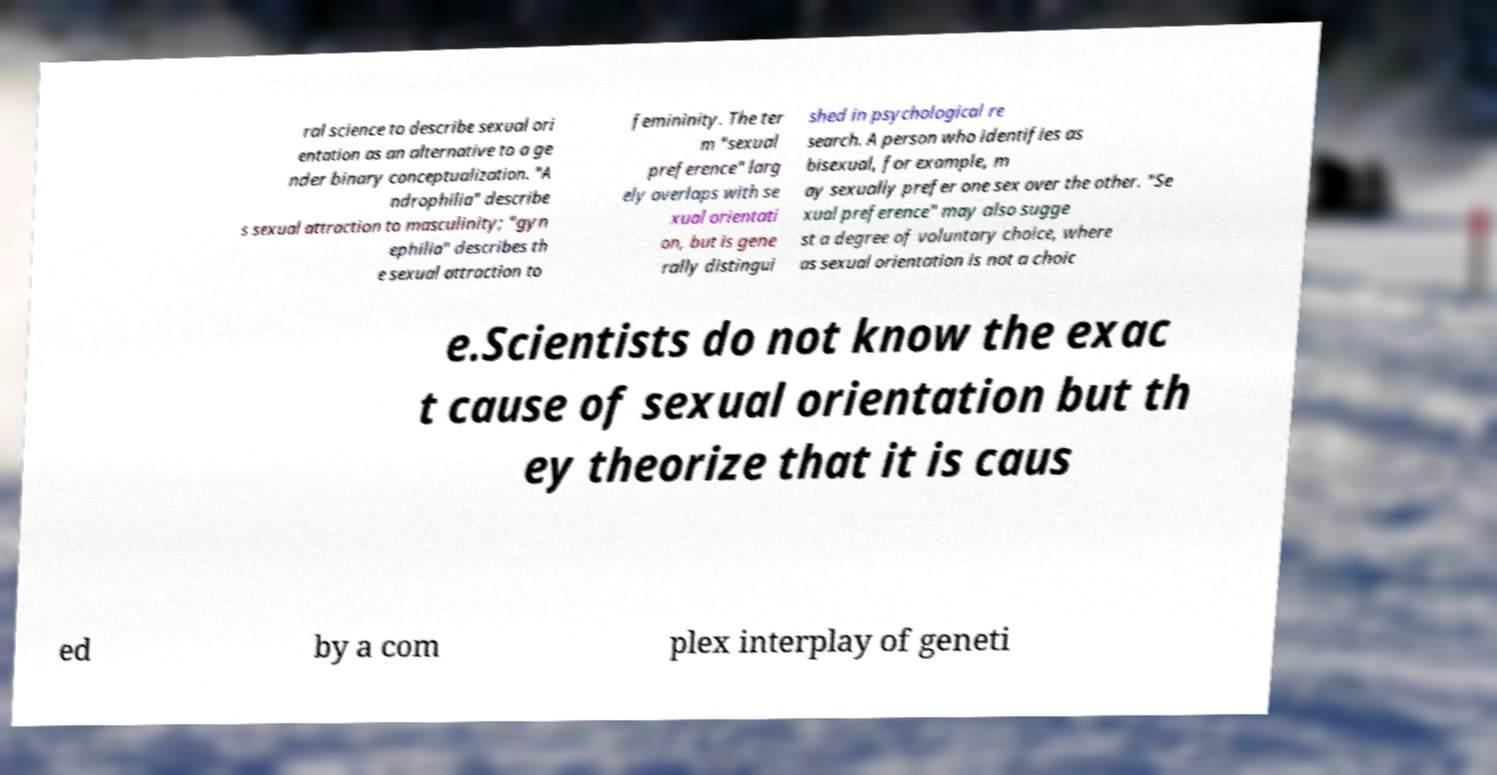Could you assist in decoding the text presented in this image and type it out clearly? ral science to describe sexual ori entation as an alternative to a ge nder binary conceptualization. "A ndrophilia" describe s sexual attraction to masculinity; "gyn ephilia" describes th e sexual attraction to femininity. The ter m "sexual preference" larg ely overlaps with se xual orientati on, but is gene rally distingui shed in psychological re search. A person who identifies as bisexual, for example, m ay sexually prefer one sex over the other. "Se xual preference" may also sugge st a degree of voluntary choice, where as sexual orientation is not a choic e.Scientists do not know the exac t cause of sexual orientation but th ey theorize that it is caus ed by a com plex interplay of geneti 